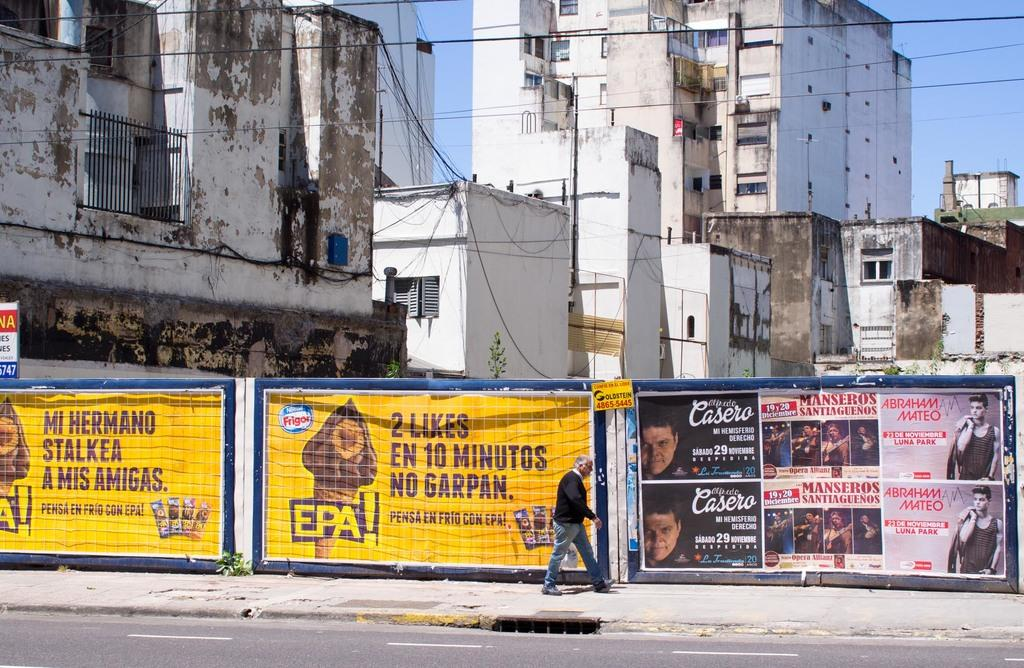<image>
Provide a brief description of the given image. A man walking down the street and there is a poster for Abrahan Mateo. 